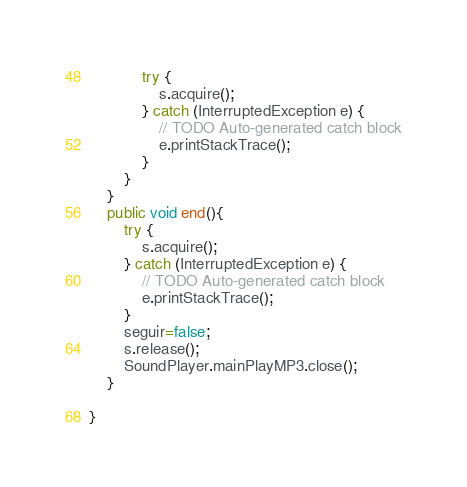Convert code to text. <code><loc_0><loc_0><loc_500><loc_500><_Java_>			try {
				s.acquire();
			} catch (InterruptedException e) {
				// TODO Auto-generated catch block
				e.printStackTrace();
			}
		}
	}
	public void end(){
		try {
			s.acquire();
		} catch (InterruptedException e) {
			// TODO Auto-generated catch block
			e.printStackTrace();
		}
		seguir=false;
		s.release();
		SoundPlayer.mainPlayMP3.close();
	}

}
</code> 